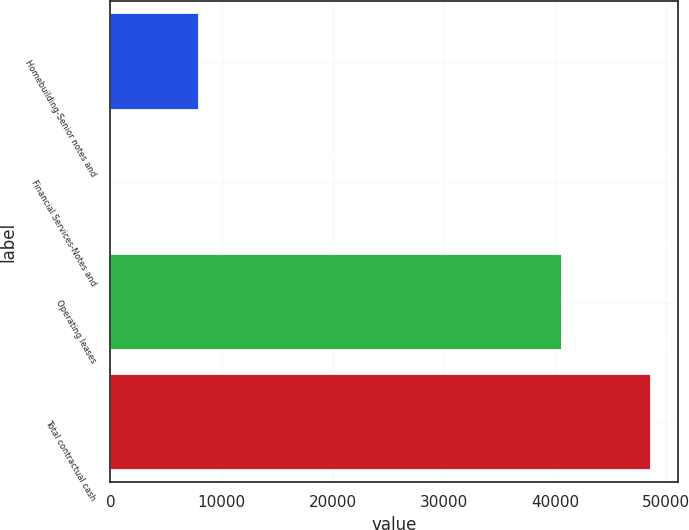<chart> <loc_0><loc_0><loc_500><loc_500><bar_chart><fcel>Homebuilding-Senior notes and<fcel>Financial Services-Notes and<fcel>Operating leases<fcel>Total contractual cash<nl><fcel>8000<fcel>17<fcel>40608<fcel>48625<nl></chart> 